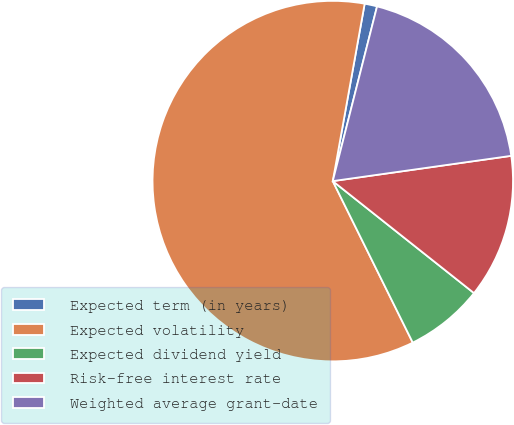<chart> <loc_0><loc_0><loc_500><loc_500><pie_chart><fcel>Expected term (in years)<fcel>Expected volatility<fcel>Expected dividend yield<fcel>Risk-free interest rate<fcel>Weighted average grant-date<nl><fcel>1.12%<fcel>60.15%<fcel>7.01%<fcel>12.91%<fcel>18.81%<nl></chart> 